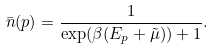Convert formula to latex. <formula><loc_0><loc_0><loc_500><loc_500>\bar { n } ( p ) = \frac { 1 } { \exp ( \beta ( E _ { p } + \tilde { \mu } ) ) + 1 } .</formula> 